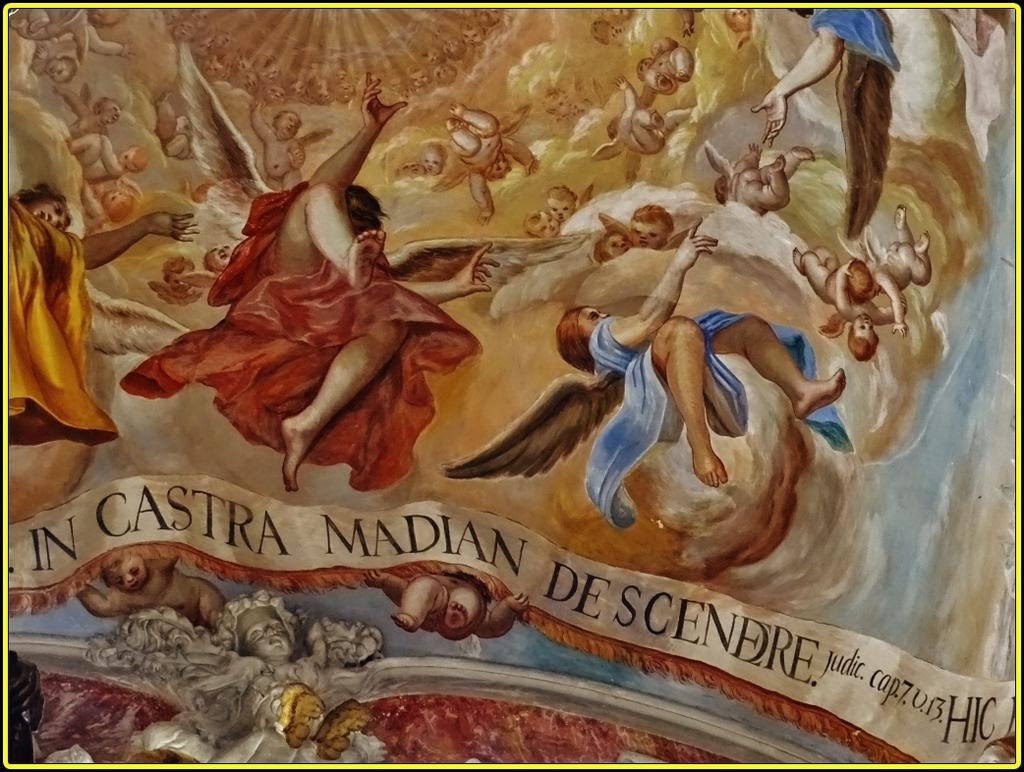<image>
Give a short and clear explanation of the subsequent image. A painting with a banner on it that says In Castra Madian. 